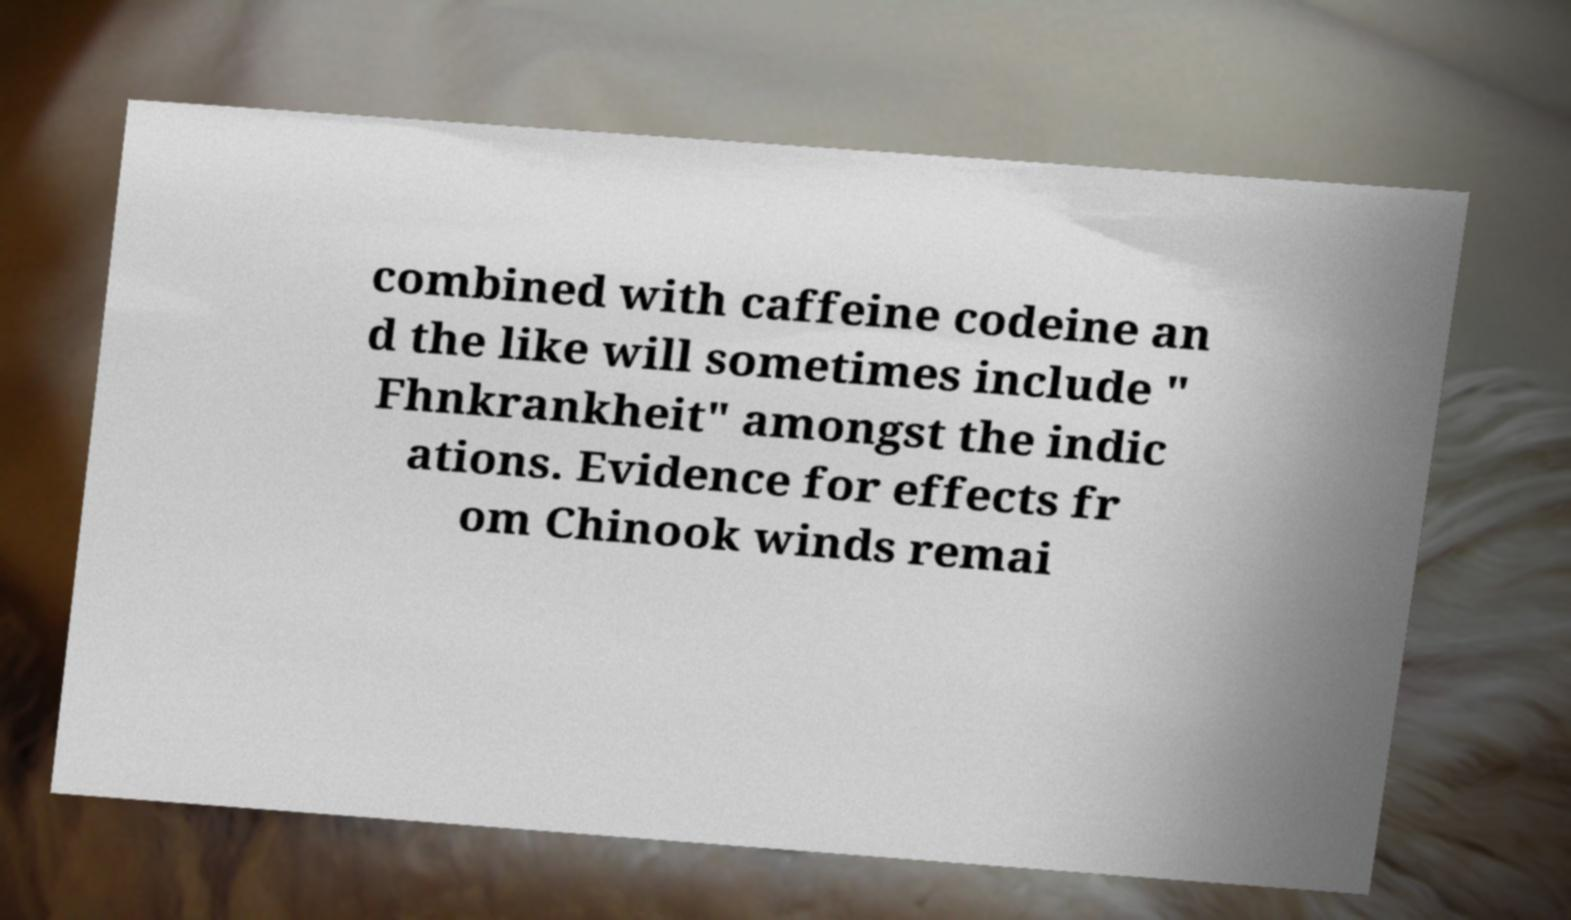Please read and relay the text visible in this image. What does it say? combined with caffeine codeine an d the like will sometimes include " Fhnkrankheit" amongst the indic ations. Evidence for effects fr om Chinook winds remai 